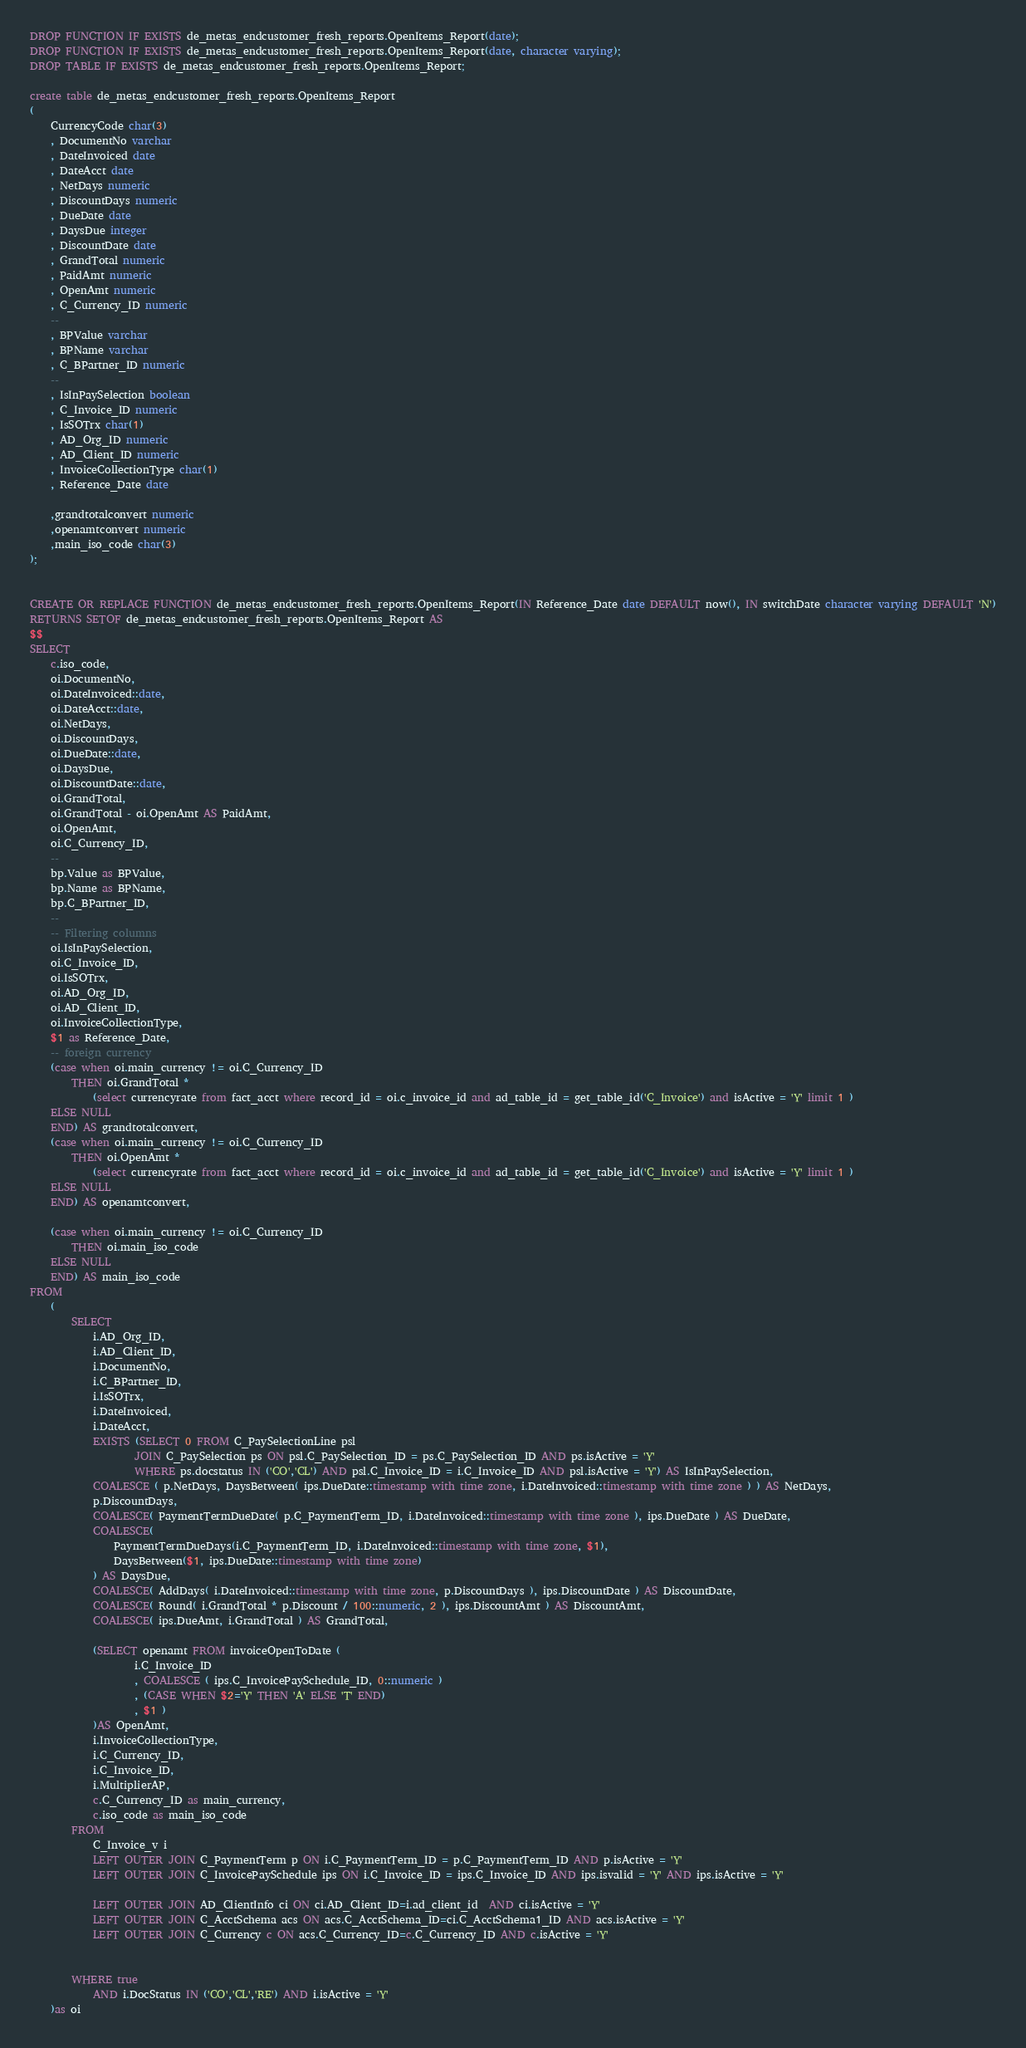Convert code to text. <code><loc_0><loc_0><loc_500><loc_500><_SQL_>DROP FUNCTION IF EXISTS de_metas_endcustomer_fresh_reports.OpenItems_Report(date);
DROP FUNCTION IF EXISTS de_metas_endcustomer_fresh_reports.OpenItems_Report(date, character varying);
DROP TABLE IF EXISTS de_metas_endcustomer_fresh_reports.OpenItems_Report;

create table de_metas_endcustomer_fresh_reports.OpenItems_Report
(
	CurrencyCode char(3)
	, DocumentNo varchar
	, DateInvoiced date
	, DateAcct date
	, NetDays numeric
	, DiscountDays numeric
	, DueDate date
	, DaysDue integer
	, DiscountDate date
	, GrandTotal numeric
	, PaidAmt numeric
	, OpenAmt numeric
	, C_Currency_ID numeric
	--
	, BPValue varchar
	, BPName varchar
	, C_BPartner_ID numeric
	--
	, IsInPaySelection boolean
	, C_Invoice_ID numeric
	, IsSOTrx char(1)
	, AD_Org_ID numeric
	, AD_Client_ID numeric
	, InvoiceCollectionType char(1)
	, Reference_Date date

	,grandtotalconvert numeric
	,openamtconvert numeric
	,main_iso_code char(3)
);


CREATE OR REPLACE FUNCTION de_metas_endcustomer_fresh_reports.OpenItems_Report(IN Reference_Date date DEFAULT now(), IN switchDate character varying DEFAULT 'N')
RETURNS SETOF de_metas_endcustomer_fresh_reports.OpenItems_Report AS
$$
SELECT
	c.iso_code,
	oi.DocumentNo,
	oi.DateInvoiced::date,
	oi.DateAcct::date,
	oi.NetDays,
	oi.DiscountDays,
	oi.DueDate::date,
	oi.DaysDue,
 	oi.DiscountDate::date,
	oi.GrandTotal,
	oi.GrandTotal - oi.OpenAmt AS PaidAmt,
	oi.OpenAmt,
	oi.C_Currency_ID,
	--
	bp.Value as BPValue,
	bp.Name as BPName,
	bp.C_BPartner_ID,
	--
	-- Filtering columns
	oi.IsInPaySelection,
	oi.C_Invoice_ID,
	oi.IsSOTrx,
	oi.AD_Org_ID,
	oi.AD_Client_ID,
	oi.InvoiceCollectionType,
	$1 as Reference_Date,
	-- foreign currency
	(case when oi.main_currency != oi.C_Currency_ID 
		THEN oi.GrandTotal * 
			(select currencyrate from fact_acct where record_id = oi.c_invoice_id and ad_table_id = get_table_id('C_Invoice') and isActive = 'Y' limit 1 ) 
	ELSE NULL 
	END) AS grandtotalconvert,
	(case when oi.main_currency != oi.C_Currency_ID 
		THEN oi.OpenAmt * 
			(select currencyrate from fact_acct where record_id = oi.c_invoice_id and ad_table_id = get_table_id('C_Invoice') and isActive = 'Y' limit 1 ) 
	ELSE NULL 
	END) AS openamtconvert,

	(case when oi.main_currency != oi.C_Currency_ID 
		THEN oi.main_iso_code
	ELSE NULL
	END) AS main_iso_code
FROM
	(
		SELECT
			i.AD_Org_ID,
			i.AD_Client_ID,
			i.DocumentNo,
			i.C_BPartner_ID,
			i.IsSOTrx,
			i.DateInvoiced,
			i.DateAcct,
			EXISTS (SELECT 0 FROM C_PaySelectionLine psl 
					JOIN C_PaySelection ps ON psl.C_PaySelection_ID = ps.C_PaySelection_ID AND ps.isActive = 'Y'
					WHERE ps.docstatus IN ('CO','CL') AND psl.C_Invoice_ID = i.C_Invoice_ID AND psl.isActive = 'Y') AS IsInPaySelection,
			COALESCE ( p.NetDays, DaysBetween( ips.DueDate::timestamp with time zone, i.DateInvoiced::timestamp with time zone ) ) AS NetDays,
			p.DiscountDays,
			COALESCE( PaymentTermDueDate( p.C_PaymentTerm_ID, i.DateInvoiced::timestamp with time zone ), ips.DueDate ) AS DueDate,
			COALESCE(
				PaymentTermDueDays(i.C_PaymentTerm_ID, i.DateInvoiced::timestamp with time zone, $1),
				DaysBetween($1, ips.DueDate::timestamp with time zone)
			) AS DaysDue,
			COALESCE( AddDays( i.DateInvoiced::timestamp with time zone, p.DiscountDays ), ips.DiscountDate ) AS DiscountDate,
			COALESCE( Round( i.GrandTotal * p.Discount / 100::numeric, 2 ), ips.DiscountAmt ) AS DiscountAmt,
			COALESCE( ips.DueAmt, i.GrandTotal ) AS GrandTotal,
			
			(SELECT openamt FROM invoiceOpenToDate ( 
					i.C_Invoice_ID
					, COALESCE ( ips.C_InvoicePaySchedule_ID, 0::numeric )
					, (CASE WHEN $2='Y' THEN 'A' ELSE 'T' END)
					, $1 ) 
			)AS OpenAmt,
			i.InvoiceCollectionType,
			i.C_Currency_ID,
			i.C_Invoice_ID,
			i.MultiplierAP,
			c.C_Currency_ID as main_currency,
			c.iso_code as main_iso_code
		FROM
			C_Invoice_v i
			LEFT OUTER JOIN C_PaymentTerm p ON i.C_PaymentTerm_ID = p.C_PaymentTerm_ID AND p.isActive = 'Y'
			LEFT OUTER JOIN C_InvoicePaySchedule ips ON i.C_Invoice_ID = ips.C_Invoice_ID AND ips.isvalid = 'Y' AND ips.isActive = 'Y'
			
			LEFT OUTER JOIN AD_ClientInfo ci ON ci.AD_Client_ID=i.ad_client_id  AND ci.isActive = 'Y'
			LEFT OUTER JOIN C_AcctSchema acs ON acs.C_AcctSchema_ID=ci.C_AcctSchema1_ID AND acs.isActive = 'Y'
			LEFT OUTER JOIN C_Currency c ON acs.C_Currency_ID=c.C_Currency_ID AND c.isActive = 'Y'
			

		WHERE true
			AND i.DocStatus IN ('CO','CL','RE') AND i.isActive = 'Y'
	)as oi</code> 